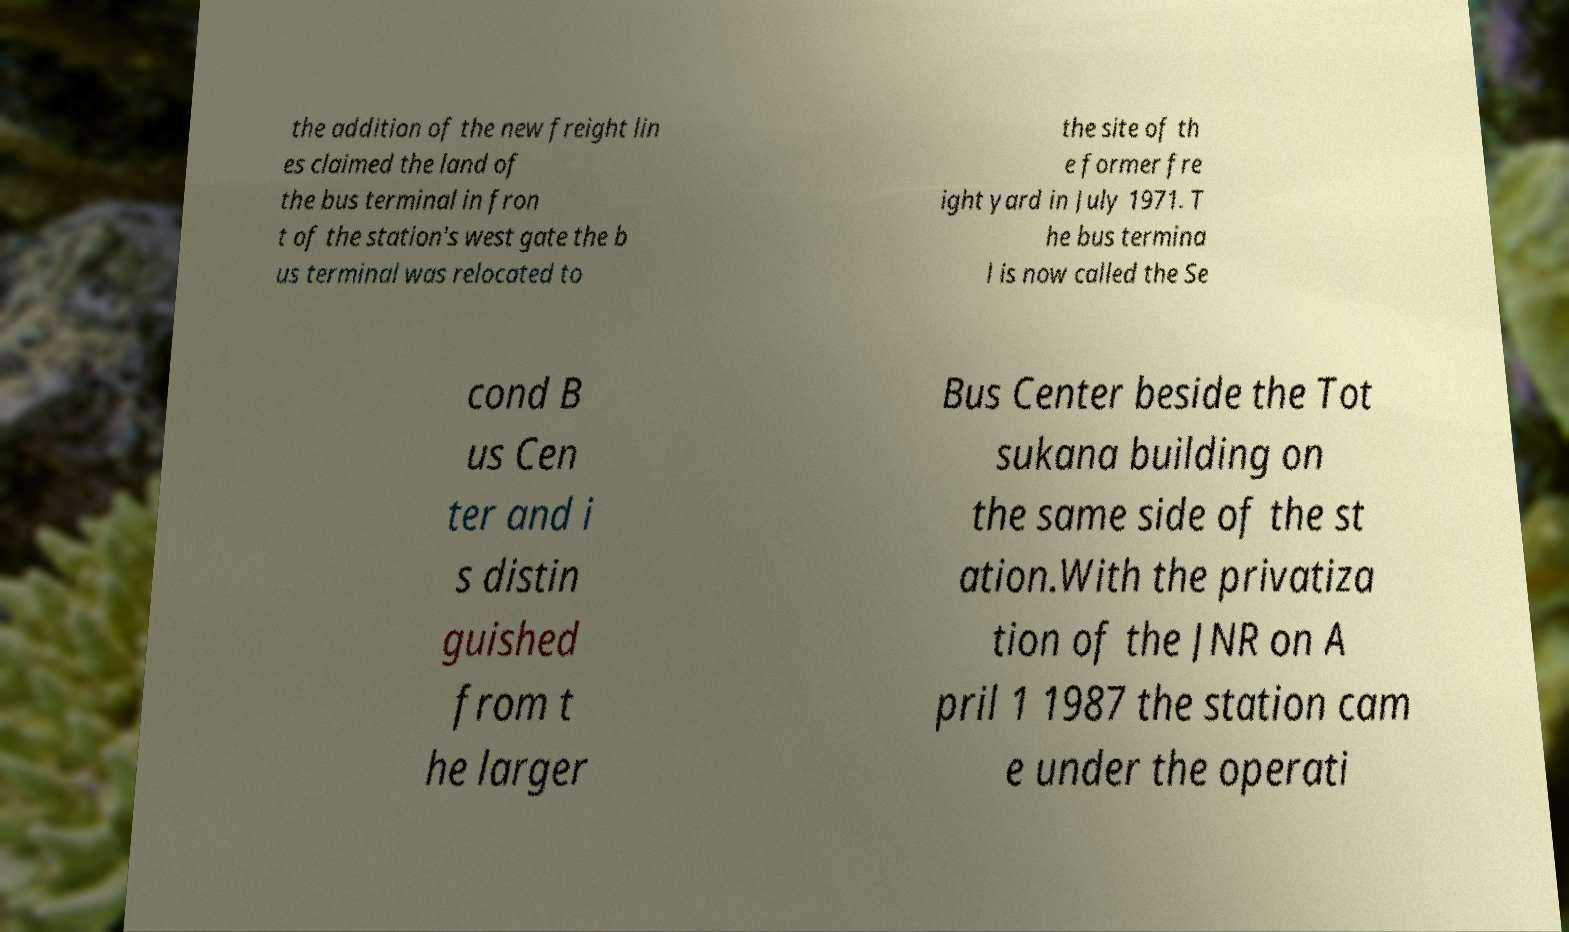Could you extract and type out the text from this image? the addition of the new freight lin es claimed the land of the bus terminal in fron t of the station's west gate the b us terminal was relocated to the site of th e former fre ight yard in July 1971. T he bus termina l is now called the Se cond B us Cen ter and i s distin guished from t he larger Bus Center beside the Tot sukana building on the same side of the st ation.With the privatiza tion of the JNR on A pril 1 1987 the station cam e under the operati 